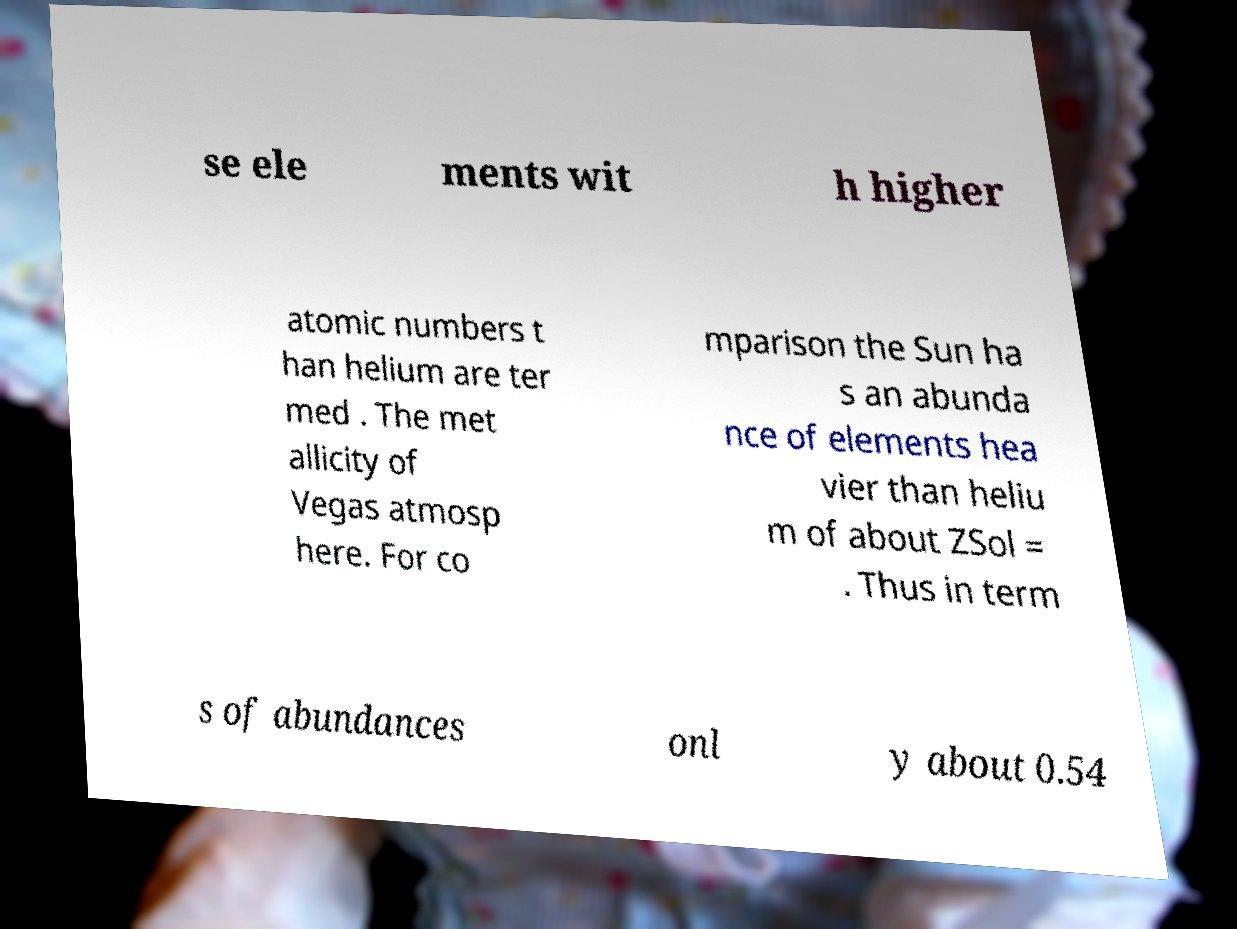There's text embedded in this image that I need extracted. Can you transcribe it verbatim? se ele ments wit h higher atomic numbers t han helium are ter med . The met allicity of Vegas atmosp here. For co mparison the Sun ha s an abunda nce of elements hea vier than heliu m of about ZSol = . Thus in term s of abundances onl y about 0.54 